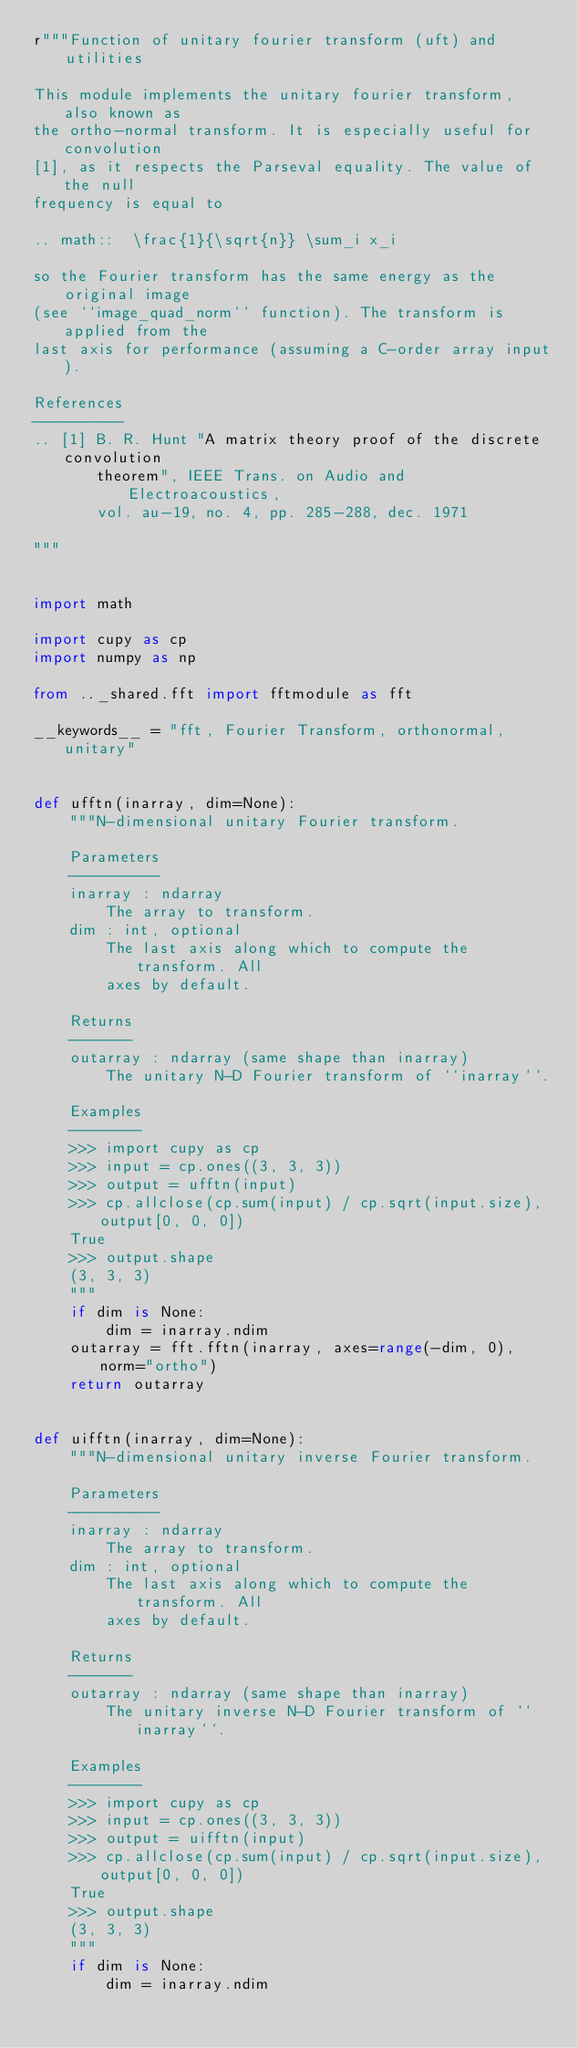Convert code to text. <code><loc_0><loc_0><loc_500><loc_500><_Python_>r"""Function of unitary fourier transform (uft) and utilities

This module implements the unitary fourier transform, also known as
the ortho-normal transform. It is especially useful for convolution
[1], as it respects the Parseval equality. The value of the null
frequency is equal to

.. math::  \frac{1}{\sqrt{n}} \sum_i x_i

so the Fourier transform has the same energy as the original image
(see ``image_quad_norm`` function). The transform is applied from the
last axis for performance (assuming a C-order array input).

References
----------
.. [1] B. R. Hunt "A matrix theory proof of the discrete convolution
       theorem", IEEE Trans. on Audio and Electroacoustics,
       vol. au-19, no. 4, pp. 285-288, dec. 1971

"""


import math

import cupy as cp
import numpy as np

from .._shared.fft import fftmodule as fft

__keywords__ = "fft, Fourier Transform, orthonormal, unitary"


def ufftn(inarray, dim=None):
    """N-dimensional unitary Fourier transform.

    Parameters
    ----------
    inarray : ndarray
        The array to transform.
    dim : int, optional
        The last axis along which to compute the transform. All
        axes by default.

    Returns
    -------
    outarray : ndarray (same shape than inarray)
        The unitary N-D Fourier transform of ``inarray``.

    Examples
    --------
    >>> import cupy as cp
    >>> input = cp.ones((3, 3, 3))
    >>> output = ufftn(input)
    >>> cp.allclose(cp.sum(input) / cp.sqrt(input.size), output[0, 0, 0])
    True
    >>> output.shape
    (3, 3, 3)
    """
    if dim is None:
        dim = inarray.ndim
    outarray = fft.fftn(inarray, axes=range(-dim, 0), norm="ortho")
    return outarray


def uifftn(inarray, dim=None):
    """N-dimensional unitary inverse Fourier transform.

    Parameters
    ----------
    inarray : ndarray
        The array to transform.
    dim : int, optional
        The last axis along which to compute the transform. All
        axes by default.

    Returns
    -------
    outarray : ndarray (same shape than inarray)
        The unitary inverse N-D Fourier transform of ``inarray``.

    Examples
    --------
    >>> import cupy as cp
    >>> input = cp.ones((3, 3, 3))
    >>> output = uifftn(input)
    >>> cp.allclose(cp.sum(input) / cp.sqrt(input.size), output[0, 0, 0])
    True
    >>> output.shape
    (3, 3, 3)
    """
    if dim is None:
        dim = inarray.ndim</code> 